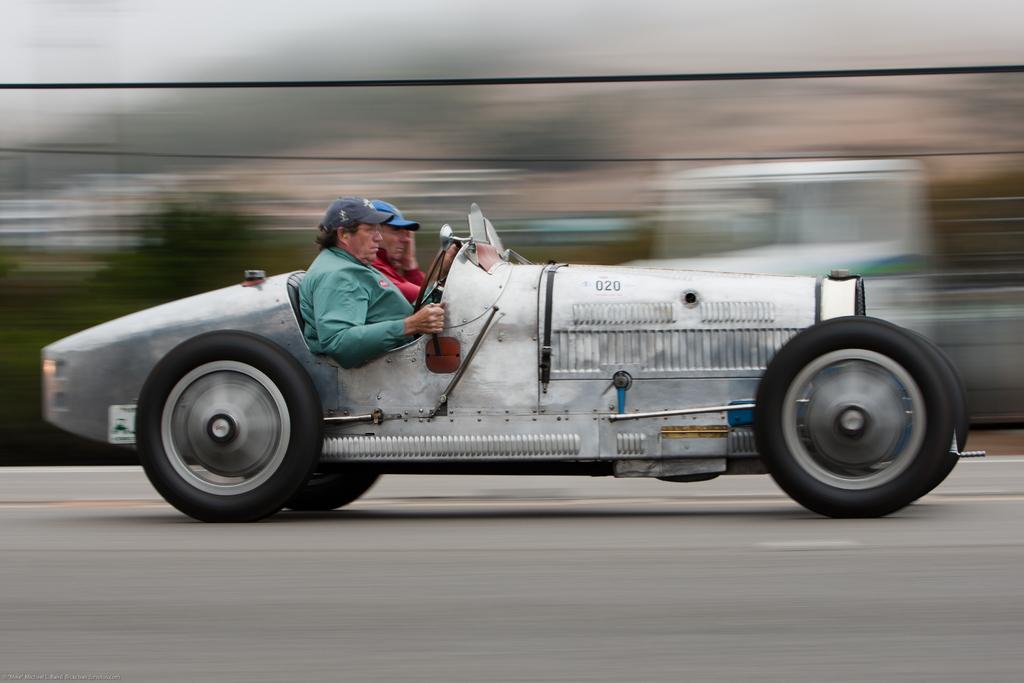How many people are in the image? There are two persons in the image. Where are the two persons located? The two persons are inside a vehicle. What can be seen in the background of the image? There is a road visible in the image. What type of jelly can be seen on the road in the image? There is no jelly present on the road in the image. How many trucks are visible in the image? There is no information about trucks in the image; it only mentions a road and two persons inside a vehicle. 